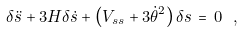Convert formula to latex. <formula><loc_0><loc_0><loc_500><loc_500>\delta \ddot { s } + 3 H \delta \dot { s } + \left ( V _ { s s } + 3 \dot { \theta } ^ { 2 } \right ) \delta s \, = \, 0 \ ,</formula> 